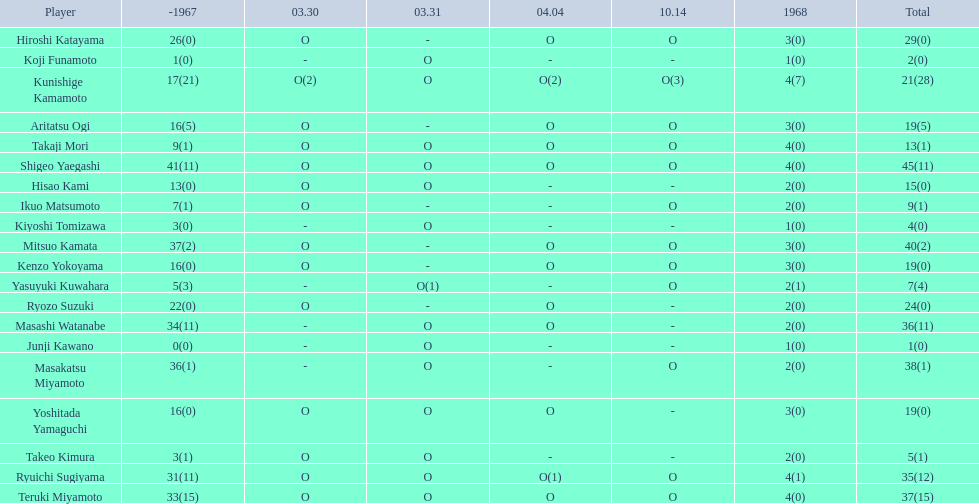How many points did takaji mori have? 13(1). And how many points did junji kawano have? 1(0). To who does the higher of these belong to? Takaji Mori. 